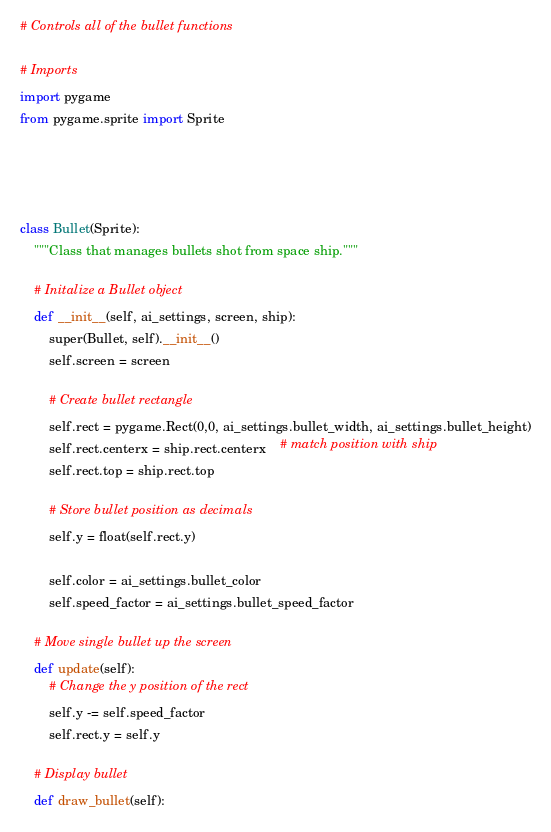Convert code to text. <code><loc_0><loc_0><loc_500><loc_500><_Python_># Controls all of the bullet functions

# Imports
import pygame
from pygame.sprite import Sprite




class Bullet(Sprite):
    """Class that manages bullets shot from space ship."""

    # Initalize a Bullet object
    def __init__(self, ai_settings, screen, ship):
        super(Bullet, self).__init__()
        self.screen = screen

        # Create bullet rectangle
        self.rect = pygame.Rect(0,0, ai_settings.bullet_width, ai_settings.bullet_height)
        self.rect.centerx = ship.rect.centerx    # match position with ship
        self.rect.top = ship.rect.top

        # Store bullet position as decimals
        self.y = float(self.rect.y)

        self.color = ai_settings.bullet_color
        self.speed_factor = ai_settings.bullet_speed_factor

    # Move single bullet up the screen
    def update(self):
        # Change the y position of the rect
        self.y -= self.speed_factor
        self.rect.y = self.y

    # Display bullet
    def draw_bullet(self):</code> 